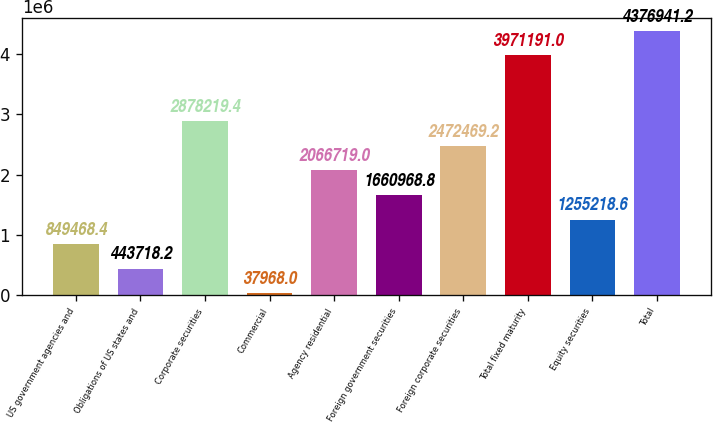<chart> <loc_0><loc_0><loc_500><loc_500><bar_chart><fcel>US government agencies and<fcel>Obligations of US states and<fcel>Corporate securities<fcel>Commercial<fcel>Agency residential<fcel>Foreign government securities<fcel>Foreign corporate securities<fcel>Total fixed maturity<fcel>Equity securities<fcel>Total<nl><fcel>849468<fcel>443718<fcel>2.87822e+06<fcel>37968<fcel>2.06672e+06<fcel>1.66097e+06<fcel>2.47247e+06<fcel>3.97119e+06<fcel>1.25522e+06<fcel>4.37694e+06<nl></chart> 